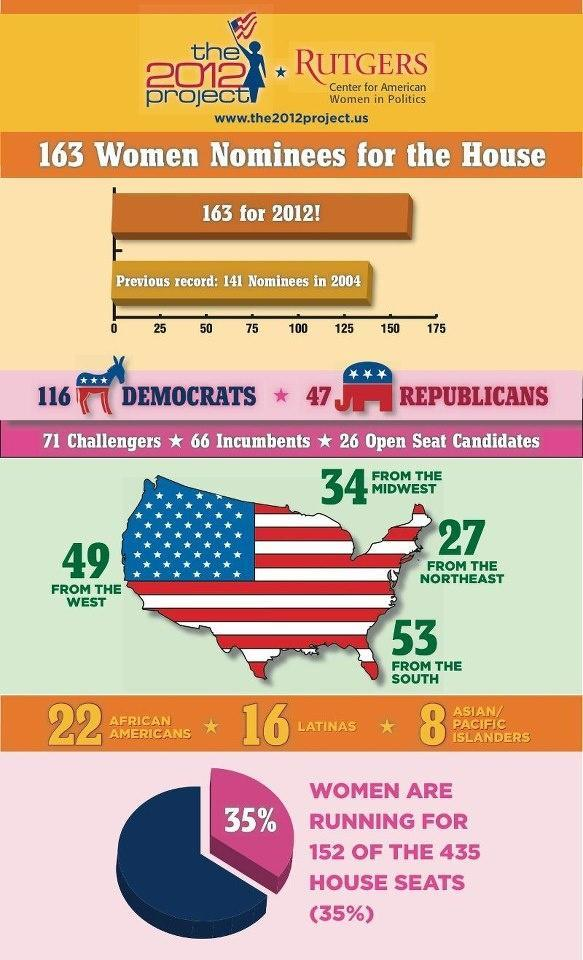what is the total number of women nominees who are not challengers?
Answer the question with a short phrase. 92 what is the total number of women nominees who are African Americans, Latinas or Asian/pacific islanders? 46 what is the total number of women nominees who are African Americansn or Asian/pacific islanders? 30 what is the total number of women nominees who are African Americans or Latinas? 38 what is the total number of women nominees who are African Americans or Asian/pacific islanders? 24 what is the total number of women nominees from the north east and the South? 80 which party have more women nominees - republican or democrat? democrat what is the total number of women nominees who are not open seat candidates? 137 what is the total number of women nominees who are not from the South? 110 what is the total number of women nominees from the west and the Midwest? 83 